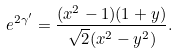Convert formula to latex. <formula><loc_0><loc_0><loc_500><loc_500>e ^ { 2 \gamma ^ { \prime } } = \frac { ( x ^ { 2 } - 1 ) ( 1 + y ) } { \sqrt { 2 } ( x ^ { 2 } - y ^ { 2 } ) } .</formula> 